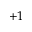<formula> <loc_0><loc_0><loc_500><loc_500>+ 1</formula> 